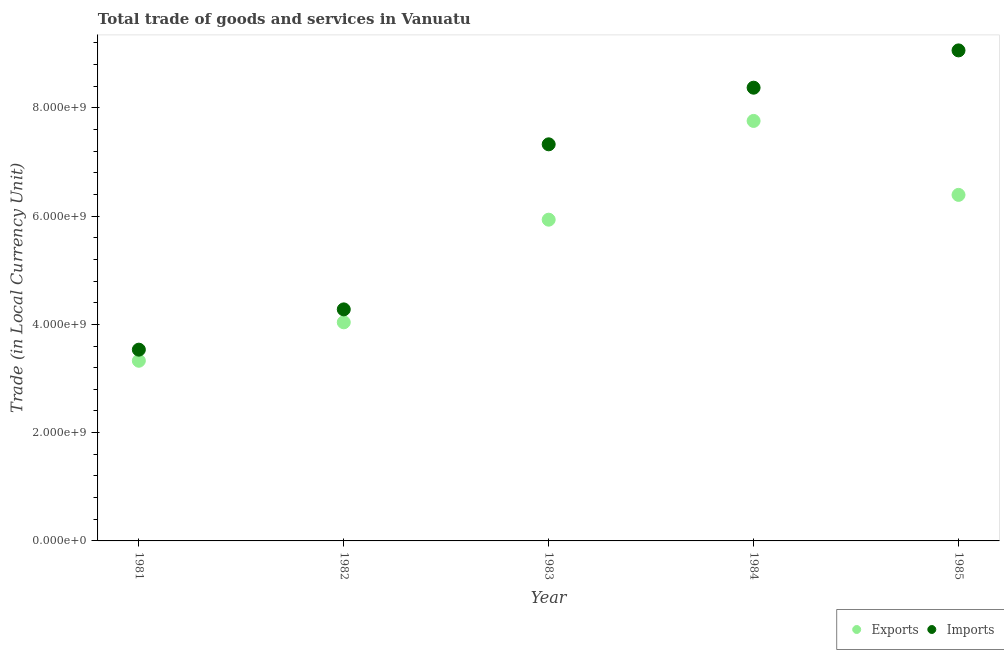How many different coloured dotlines are there?
Keep it short and to the point. 2. What is the imports of goods and services in 1982?
Your answer should be very brief. 4.28e+09. Across all years, what is the maximum export of goods and services?
Offer a very short reply. 7.76e+09. Across all years, what is the minimum export of goods and services?
Give a very brief answer. 3.33e+09. In which year was the export of goods and services minimum?
Ensure brevity in your answer.  1981. What is the total export of goods and services in the graph?
Offer a very short reply. 2.74e+1. What is the difference between the imports of goods and services in 1982 and that in 1985?
Offer a terse response. -4.78e+09. What is the difference between the export of goods and services in 1982 and the imports of goods and services in 1984?
Offer a very short reply. -4.33e+09. What is the average imports of goods and services per year?
Offer a very short reply. 6.51e+09. In the year 1981, what is the difference between the export of goods and services and imports of goods and services?
Your answer should be compact. -2.05e+08. In how many years, is the export of goods and services greater than 5600000000 LCU?
Give a very brief answer. 3. What is the ratio of the imports of goods and services in 1982 to that in 1984?
Offer a very short reply. 0.51. Is the difference between the imports of goods and services in 1983 and 1984 greater than the difference between the export of goods and services in 1983 and 1984?
Offer a very short reply. Yes. What is the difference between the highest and the second highest imports of goods and services?
Provide a short and direct response. 6.89e+08. What is the difference between the highest and the lowest imports of goods and services?
Give a very brief answer. 5.53e+09. How many years are there in the graph?
Your answer should be compact. 5. What is the difference between two consecutive major ticks on the Y-axis?
Provide a succinct answer. 2.00e+09. Does the graph contain any zero values?
Keep it short and to the point. No. Does the graph contain grids?
Make the answer very short. No. Where does the legend appear in the graph?
Your answer should be very brief. Bottom right. How many legend labels are there?
Your answer should be very brief. 2. How are the legend labels stacked?
Give a very brief answer. Horizontal. What is the title of the graph?
Provide a short and direct response. Total trade of goods and services in Vanuatu. What is the label or title of the X-axis?
Keep it short and to the point. Year. What is the label or title of the Y-axis?
Your answer should be compact. Trade (in Local Currency Unit). What is the Trade (in Local Currency Unit) in Exports in 1981?
Keep it short and to the point. 3.33e+09. What is the Trade (in Local Currency Unit) of Imports in 1981?
Provide a succinct answer. 3.53e+09. What is the Trade (in Local Currency Unit) in Exports in 1982?
Give a very brief answer. 4.04e+09. What is the Trade (in Local Currency Unit) in Imports in 1982?
Your response must be concise. 4.28e+09. What is the Trade (in Local Currency Unit) of Exports in 1983?
Offer a very short reply. 5.93e+09. What is the Trade (in Local Currency Unit) of Imports in 1983?
Provide a succinct answer. 7.33e+09. What is the Trade (in Local Currency Unit) of Exports in 1984?
Make the answer very short. 7.76e+09. What is the Trade (in Local Currency Unit) in Imports in 1984?
Offer a terse response. 8.37e+09. What is the Trade (in Local Currency Unit) in Exports in 1985?
Keep it short and to the point. 6.39e+09. What is the Trade (in Local Currency Unit) in Imports in 1985?
Keep it short and to the point. 9.06e+09. Across all years, what is the maximum Trade (in Local Currency Unit) in Exports?
Provide a succinct answer. 7.76e+09. Across all years, what is the maximum Trade (in Local Currency Unit) of Imports?
Ensure brevity in your answer.  9.06e+09. Across all years, what is the minimum Trade (in Local Currency Unit) of Exports?
Your answer should be very brief. 3.33e+09. Across all years, what is the minimum Trade (in Local Currency Unit) of Imports?
Make the answer very short. 3.53e+09. What is the total Trade (in Local Currency Unit) of Exports in the graph?
Make the answer very short. 2.74e+1. What is the total Trade (in Local Currency Unit) in Imports in the graph?
Provide a short and direct response. 3.26e+1. What is the difference between the Trade (in Local Currency Unit) of Exports in 1981 and that in 1982?
Provide a short and direct response. -7.10e+08. What is the difference between the Trade (in Local Currency Unit) in Imports in 1981 and that in 1982?
Provide a short and direct response. -7.44e+08. What is the difference between the Trade (in Local Currency Unit) in Exports in 1981 and that in 1983?
Provide a succinct answer. -2.61e+09. What is the difference between the Trade (in Local Currency Unit) in Imports in 1981 and that in 1983?
Provide a succinct answer. -3.79e+09. What is the difference between the Trade (in Local Currency Unit) in Exports in 1981 and that in 1984?
Make the answer very short. -4.43e+09. What is the difference between the Trade (in Local Currency Unit) of Imports in 1981 and that in 1984?
Offer a very short reply. -4.84e+09. What is the difference between the Trade (in Local Currency Unit) in Exports in 1981 and that in 1985?
Provide a succinct answer. -3.06e+09. What is the difference between the Trade (in Local Currency Unit) of Imports in 1981 and that in 1985?
Provide a short and direct response. -5.53e+09. What is the difference between the Trade (in Local Currency Unit) in Exports in 1982 and that in 1983?
Provide a succinct answer. -1.90e+09. What is the difference between the Trade (in Local Currency Unit) in Imports in 1982 and that in 1983?
Keep it short and to the point. -3.05e+09. What is the difference between the Trade (in Local Currency Unit) of Exports in 1982 and that in 1984?
Keep it short and to the point. -3.72e+09. What is the difference between the Trade (in Local Currency Unit) of Imports in 1982 and that in 1984?
Your answer should be very brief. -4.10e+09. What is the difference between the Trade (in Local Currency Unit) of Exports in 1982 and that in 1985?
Offer a very short reply. -2.35e+09. What is the difference between the Trade (in Local Currency Unit) of Imports in 1982 and that in 1985?
Your answer should be compact. -4.78e+09. What is the difference between the Trade (in Local Currency Unit) of Exports in 1983 and that in 1984?
Ensure brevity in your answer.  -1.82e+09. What is the difference between the Trade (in Local Currency Unit) of Imports in 1983 and that in 1984?
Ensure brevity in your answer.  -1.05e+09. What is the difference between the Trade (in Local Currency Unit) in Exports in 1983 and that in 1985?
Your answer should be compact. -4.58e+08. What is the difference between the Trade (in Local Currency Unit) of Imports in 1983 and that in 1985?
Provide a short and direct response. -1.74e+09. What is the difference between the Trade (in Local Currency Unit) of Exports in 1984 and that in 1985?
Offer a very short reply. 1.37e+09. What is the difference between the Trade (in Local Currency Unit) in Imports in 1984 and that in 1985?
Your answer should be compact. -6.89e+08. What is the difference between the Trade (in Local Currency Unit) in Exports in 1981 and the Trade (in Local Currency Unit) in Imports in 1982?
Your answer should be compact. -9.49e+08. What is the difference between the Trade (in Local Currency Unit) of Exports in 1981 and the Trade (in Local Currency Unit) of Imports in 1983?
Your response must be concise. -4.00e+09. What is the difference between the Trade (in Local Currency Unit) in Exports in 1981 and the Trade (in Local Currency Unit) in Imports in 1984?
Your answer should be very brief. -5.04e+09. What is the difference between the Trade (in Local Currency Unit) in Exports in 1981 and the Trade (in Local Currency Unit) in Imports in 1985?
Provide a short and direct response. -5.73e+09. What is the difference between the Trade (in Local Currency Unit) of Exports in 1982 and the Trade (in Local Currency Unit) of Imports in 1983?
Your answer should be very brief. -3.29e+09. What is the difference between the Trade (in Local Currency Unit) of Exports in 1982 and the Trade (in Local Currency Unit) of Imports in 1984?
Make the answer very short. -4.33e+09. What is the difference between the Trade (in Local Currency Unit) in Exports in 1982 and the Trade (in Local Currency Unit) in Imports in 1985?
Keep it short and to the point. -5.02e+09. What is the difference between the Trade (in Local Currency Unit) of Exports in 1983 and the Trade (in Local Currency Unit) of Imports in 1984?
Provide a short and direct response. -2.44e+09. What is the difference between the Trade (in Local Currency Unit) in Exports in 1983 and the Trade (in Local Currency Unit) in Imports in 1985?
Your response must be concise. -3.13e+09. What is the difference between the Trade (in Local Currency Unit) in Exports in 1984 and the Trade (in Local Currency Unit) in Imports in 1985?
Provide a succinct answer. -1.30e+09. What is the average Trade (in Local Currency Unit) of Exports per year?
Keep it short and to the point. 5.49e+09. What is the average Trade (in Local Currency Unit) in Imports per year?
Keep it short and to the point. 6.51e+09. In the year 1981, what is the difference between the Trade (in Local Currency Unit) of Exports and Trade (in Local Currency Unit) of Imports?
Offer a terse response. -2.05e+08. In the year 1982, what is the difference between the Trade (in Local Currency Unit) of Exports and Trade (in Local Currency Unit) of Imports?
Offer a terse response. -2.39e+08. In the year 1983, what is the difference between the Trade (in Local Currency Unit) in Exports and Trade (in Local Currency Unit) in Imports?
Your answer should be very brief. -1.39e+09. In the year 1984, what is the difference between the Trade (in Local Currency Unit) of Exports and Trade (in Local Currency Unit) of Imports?
Offer a terse response. -6.14e+08. In the year 1985, what is the difference between the Trade (in Local Currency Unit) of Exports and Trade (in Local Currency Unit) of Imports?
Ensure brevity in your answer.  -2.67e+09. What is the ratio of the Trade (in Local Currency Unit) of Exports in 1981 to that in 1982?
Keep it short and to the point. 0.82. What is the ratio of the Trade (in Local Currency Unit) of Imports in 1981 to that in 1982?
Your answer should be compact. 0.83. What is the ratio of the Trade (in Local Currency Unit) in Exports in 1981 to that in 1983?
Ensure brevity in your answer.  0.56. What is the ratio of the Trade (in Local Currency Unit) of Imports in 1981 to that in 1983?
Ensure brevity in your answer.  0.48. What is the ratio of the Trade (in Local Currency Unit) in Exports in 1981 to that in 1984?
Ensure brevity in your answer.  0.43. What is the ratio of the Trade (in Local Currency Unit) in Imports in 1981 to that in 1984?
Your answer should be compact. 0.42. What is the ratio of the Trade (in Local Currency Unit) of Exports in 1981 to that in 1985?
Provide a short and direct response. 0.52. What is the ratio of the Trade (in Local Currency Unit) of Imports in 1981 to that in 1985?
Make the answer very short. 0.39. What is the ratio of the Trade (in Local Currency Unit) of Exports in 1982 to that in 1983?
Ensure brevity in your answer.  0.68. What is the ratio of the Trade (in Local Currency Unit) of Imports in 1982 to that in 1983?
Provide a succinct answer. 0.58. What is the ratio of the Trade (in Local Currency Unit) in Exports in 1982 to that in 1984?
Provide a succinct answer. 0.52. What is the ratio of the Trade (in Local Currency Unit) of Imports in 1982 to that in 1984?
Your response must be concise. 0.51. What is the ratio of the Trade (in Local Currency Unit) in Exports in 1982 to that in 1985?
Ensure brevity in your answer.  0.63. What is the ratio of the Trade (in Local Currency Unit) of Imports in 1982 to that in 1985?
Make the answer very short. 0.47. What is the ratio of the Trade (in Local Currency Unit) in Exports in 1983 to that in 1984?
Offer a very short reply. 0.76. What is the ratio of the Trade (in Local Currency Unit) of Imports in 1983 to that in 1984?
Keep it short and to the point. 0.88. What is the ratio of the Trade (in Local Currency Unit) of Exports in 1983 to that in 1985?
Give a very brief answer. 0.93. What is the ratio of the Trade (in Local Currency Unit) of Imports in 1983 to that in 1985?
Your response must be concise. 0.81. What is the ratio of the Trade (in Local Currency Unit) in Exports in 1984 to that in 1985?
Keep it short and to the point. 1.21. What is the ratio of the Trade (in Local Currency Unit) of Imports in 1984 to that in 1985?
Your answer should be compact. 0.92. What is the difference between the highest and the second highest Trade (in Local Currency Unit) in Exports?
Offer a very short reply. 1.37e+09. What is the difference between the highest and the second highest Trade (in Local Currency Unit) in Imports?
Make the answer very short. 6.89e+08. What is the difference between the highest and the lowest Trade (in Local Currency Unit) in Exports?
Give a very brief answer. 4.43e+09. What is the difference between the highest and the lowest Trade (in Local Currency Unit) of Imports?
Give a very brief answer. 5.53e+09. 